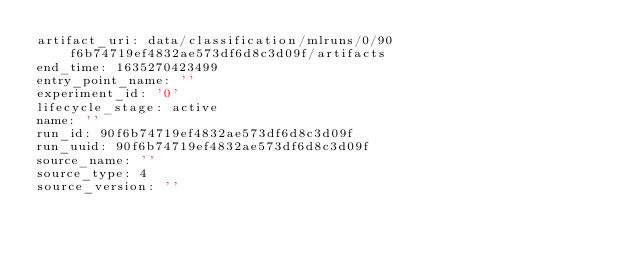Convert code to text. <code><loc_0><loc_0><loc_500><loc_500><_YAML_>artifact_uri: data/classification/mlruns/0/90f6b74719ef4832ae573df6d8c3d09f/artifacts
end_time: 1635270423499
entry_point_name: ''
experiment_id: '0'
lifecycle_stage: active
name: ''
run_id: 90f6b74719ef4832ae573df6d8c3d09f
run_uuid: 90f6b74719ef4832ae573df6d8c3d09f
source_name: ''
source_type: 4
source_version: ''</code> 